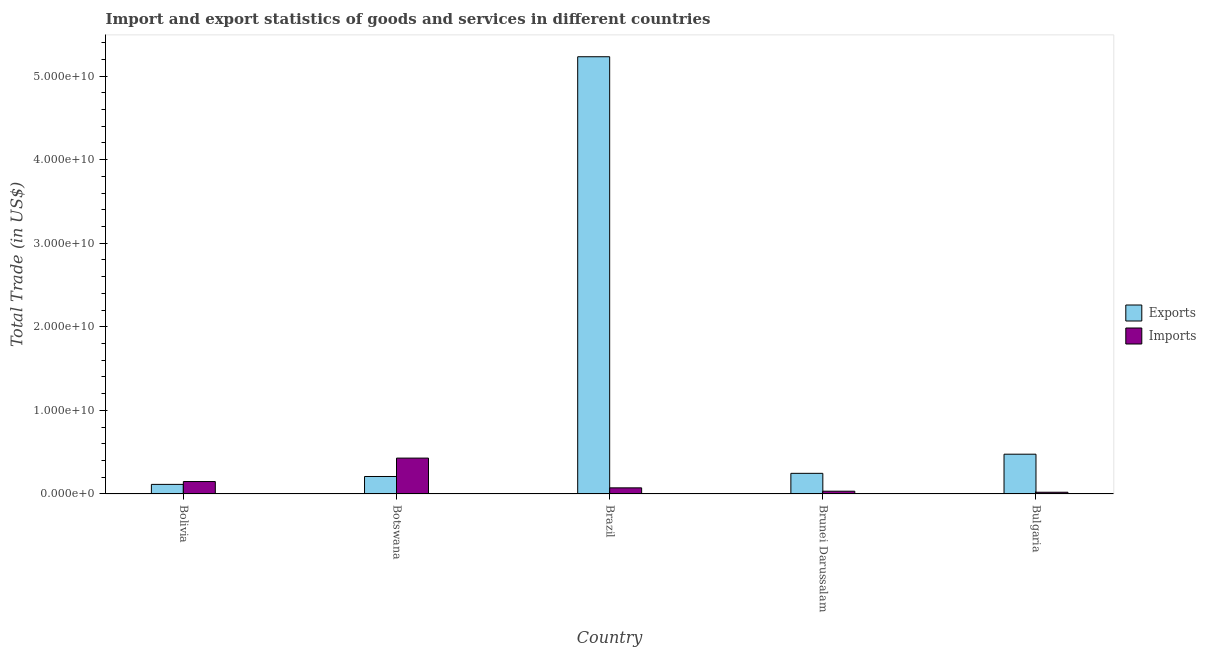How many groups of bars are there?
Ensure brevity in your answer.  5. Are the number of bars per tick equal to the number of legend labels?
Provide a succinct answer. Yes. Are the number of bars on each tick of the X-axis equal?
Make the answer very short. Yes. How many bars are there on the 5th tick from the left?
Provide a short and direct response. 2. How many bars are there on the 4th tick from the right?
Give a very brief answer. 2. In how many cases, is the number of bars for a given country not equal to the number of legend labels?
Your answer should be very brief. 0. What is the export of goods and services in Brunei Darussalam?
Provide a short and direct response. 2.47e+09. Across all countries, what is the maximum export of goods and services?
Provide a short and direct response. 5.23e+1. Across all countries, what is the minimum imports of goods and services?
Offer a terse response. 2.06e+08. What is the total imports of goods and services in the graph?
Offer a terse response. 7.05e+09. What is the difference between the export of goods and services in Brazil and that in Brunei Darussalam?
Ensure brevity in your answer.  4.98e+1. What is the difference between the export of goods and services in Brunei Darussalam and the imports of goods and services in Bulgaria?
Your answer should be compact. 2.26e+09. What is the average imports of goods and services per country?
Make the answer very short. 1.41e+09. What is the difference between the export of goods and services and imports of goods and services in Bulgaria?
Provide a short and direct response. 4.55e+09. What is the ratio of the imports of goods and services in Brazil to that in Brunei Darussalam?
Provide a short and direct response. 2.2. Is the imports of goods and services in Bolivia less than that in Brunei Darussalam?
Give a very brief answer. No. What is the difference between the highest and the second highest export of goods and services?
Provide a short and direct response. 4.76e+1. What is the difference between the highest and the lowest imports of goods and services?
Keep it short and to the point. 4.08e+09. What does the 1st bar from the left in Brunei Darussalam represents?
Make the answer very short. Exports. What does the 2nd bar from the right in Brazil represents?
Provide a succinct answer. Exports. Are all the bars in the graph horizontal?
Your answer should be very brief. No. How many countries are there in the graph?
Make the answer very short. 5. Are the values on the major ticks of Y-axis written in scientific E-notation?
Ensure brevity in your answer.  Yes. Does the graph contain grids?
Offer a very short reply. No. Where does the legend appear in the graph?
Ensure brevity in your answer.  Center right. How are the legend labels stacked?
Provide a short and direct response. Vertical. What is the title of the graph?
Your answer should be compact. Import and export statistics of goods and services in different countries. Does "Nitrous oxide" appear as one of the legend labels in the graph?
Make the answer very short. No. What is the label or title of the X-axis?
Make the answer very short. Country. What is the label or title of the Y-axis?
Your answer should be compact. Total Trade (in US$). What is the Total Trade (in US$) of Exports in Bolivia?
Your response must be concise. 1.15e+09. What is the Total Trade (in US$) in Imports in Bolivia?
Offer a very short reply. 1.49e+09. What is the Total Trade (in US$) in Exports in Botswana?
Provide a short and direct response. 2.09e+09. What is the Total Trade (in US$) in Imports in Botswana?
Ensure brevity in your answer.  4.29e+09. What is the Total Trade (in US$) in Exports in Brazil?
Offer a terse response. 5.23e+1. What is the Total Trade (in US$) in Imports in Brazil?
Ensure brevity in your answer.  7.32e+08. What is the Total Trade (in US$) in Exports in Brunei Darussalam?
Ensure brevity in your answer.  2.47e+09. What is the Total Trade (in US$) of Imports in Brunei Darussalam?
Your answer should be very brief. 3.33e+08. What is the Total Trade (in US$) in Exports in Bulgaria?
Provide a succinct answer. 4.76e+09. What is the Total Trade (in US$) in Imports in Bulgaria?
Offer a terse response. 2.06e+08. Across all countries, what is the maximum Total Trade (in US$) in Exports?
Provide a short and direct response. 5.23e+1. Across all countries, what is the maximum Total Trade (in US$) of Imports?
Make the answer very short. 4.29e+09. Across all countries, what is the minimum Total Trade (in US$) in Exports?
Give a very brief answer. 1.15e+09. Across all countries, what is the minimum Total Trade (in US$) of Imports?
Provide a short and direct response. 2.06e+08. What is the total Total Trade (in US$) of Exports in the graph?
Your answer should be compact. 6.28e+1. What is the total Total Trade (in US$) in Imports in the graph?
Provide a succinct answer. 7.05e+09. What is the difference between the Total Trade (in US$) of Exports in Bolivia and that in Botswana?
Your response must be concise. -9.43e+08. What is the difference between the Total Trade (in US$) in Imports in Bolivia and that in Botswana?
Provide a short and direct response. -2.80e+09. What is the difference between the Total Trade (in US$) of Exports in Bolivia and that in Brazil?
Offer a terse response. -5.12e+1. What is the difference between the Total Trade (in US$) in Imports in Bolivia and that in Brazil?
Keep it short and to the point. 7.55e+08. What is the difference between the Total Trade (in US$) of Exports in Bolivia and that in Brunei Darussalam?
Your answer should be very brief. -1.32e+09. What is the difference between the Total Trade (in US$) of Imports in Bolivia and that in Brunei Darussalam?
Offer a terse response. 1.15e+09. What is the difference between the Total Trade (in US$) in Exports in Bolivia and that in Bulgaria?
Provide a succinct answer. -3.61e+09. What is the difference between the Total Trade (in US$) in Imports in Bolivia and that in Bulgaria?
Keep it short and to the point. 1.28e+09. What is the difference between the Total Trade (in US$) of Exports in Botswana and that in Brazil?
Provide a succinct answer. -5.02e+1. What is the difference between the Total Trade (in US$) in Imports in Botswana and that in Brazil?
Keep it short and to the point. 3.56e+09. What is the difference between the Total Trade (in US$) of Exports in Botswana and that in Brunei Darussalam?
Your response must be concise. -3.77e+08. What is the difference between the Total Trade (in US$) of Imports in Botswana and that in Brunei Darussalam?
Make the answer very short. 3.96e+09. What is the difference between the Total Trade (in US$) of Exports in Botswana and that in Bulgaria?
Your answer should be very brief. -2.67e+09. What is the difference between the Total Trade (in US$) in Imports in Botswana and that in Bulgaria?
Offer a very short reply. 4.08e+09. What is the difference between the Total Trade (in US$) of Exports in Brazil and that in Brunei Darussalam?
Make the answer very short. 4.98e+1. What is the difference between the Total Trade (in US$) in Imports in Brazil and that in Brunei Darussalam?
Your answer should be compact. 3.99e+08. What is the difference between the Total Trade (in US$) of Exports in Brazil and that in Bulgaria?
Your answer should be compact. 4.76e+1. What is the difference between the Total Trade (in US$) in Imports in Brazil and that in Bulgaria?
Provide a succinct answer. 5.26e+08. What is the difference between the Total Trade (in US$) in Exports in Brunei Darussalam and that in Bulgaria?
Ensure brevity in your answer.  -2.29e+09. What is the difference between the Total Trade (in US$) in Imports in Brunei Darussalam and that in Bulgaria?
Keep it short and to the point. 1.27e+08. What is the difference between the Total Trade (in US$) of Exports in Bolivia and the Total Trade (in US$) of Imports in Botswana?
Provide a succinct answer. -3.14e+09. What is the difference between the Total Trade (in US$) of Exports in Bolivia and the Total Trade (in US$) of Imports in Brazil?
Give a very brief answer. 4.16e+08. What is the difference between the Total Trade (in US$) in Exports in Bolivia and the Total Trade (in US$) in Imports in Brunei Darussalam?
Provide a short and direct response. 8.15e+08. What is the difference between the Total Trade (in US$) of Exports in Bolivia and the Total Trade (in US$) of Imports in Bulgaria?
Provide a short and direct response. 9.42e+08. What is the difference between the Total Trade (in US$) of Exports in Botswana and the Total Trade (in US$) of Imports in Brazil?
Offer a very short reply. 1.36e+09. What is the difference between the Total Trade (in US$) of Exports in Botswana and the Total Trade (in US$) of Imports in Brunei Darussalam?
Offer a terse response. 1.76e+09. What is the difference between the Total Trade (in US$) in Exports in Botswana and the Total Trade (in US$) in Imports in Bulgaria?
Provide a succinct answer. 1.88e+09. What is the difference between the Total Trade (in US$) of Exports in Brazil and the Total Trade (in US$) of Imports in Brunei Darussalam?
Ensure brevity in your answer.  5.20e+1. What is the difference between the Total Trade (in US$) of Exports in Brazil and the Total Trade (in US$) of Imports in Bulgaria?
Your answer should be very brief. 5.21e+1. What is the difference between the Total Trade (in US$) in Exports in Brunei Darussalam and the Total Trade (in US$) in Imports in Bulgaria?
Make the answer very short. 2.26e+09. What is the average Total Trade (in US$) in Exports per country?
Provide a succinct answer. 1.26e+1. What is the average Total Trade (in US$) in Imports per country?
Your answer should be very brief. 1.41e+09. What is the difference between the Total Trade (in US$) in Exports and Total Trade (in US$) in Imports in Bolivia?
Provide a short and direct response. -3.39e+08. What is the difference between the Total Trade (in US$) of Exports and Total Trade (in US$) of Imports in Botswana?
Make the answer very short. -2.20e+09. What is the difference between the Total Trade (in US$) in Exports and Total Trade (in US$) in Imports in Brazil?
Your answer should be very brief. 5.16e+1. What is the difference between the Total Trade (in US$) of Exports and Total Trade (in US$) of Imports in Brunei Darussalam?
Provide a short and direct response. 2.14e+09. What is the difference between the Total Trade (in US$) of Exports and Total Trade (in US$) of Imports in Bulgaria?
Provide a succinct answer. 4.55e+09. What is the ratio of the Total Trade (in US$) of Exports in Bolivia to that in Botswana?
Provide a short and direct response. 0.55. What is the ratio of the Total Trade (in US$) of Imports in Bolivia to that in Botswana?
Offer a very short reply. 0.35. What is the ratio of the Total Trade (in US$) of Exports in Bolivia to that in Brazil?
Ensure brevity in your answer.  0.02. What is the ratio of the Total Trade (in US$) of Imports in Bolivia to that in Brazil?
Offer a very short reply. 2.03. What is the ratio of the Total Trade (in US$) in Exports in Bolivia to that in Brunei Darussalam?
Offer a terse response. 0.47. What is the ratio of the Total Trade (in US$) of Imports in Bolivia to that in Brunei Darussalam?
Give a very brief answer. 4.47. What is the ratio of the Total Trade (in US$) in Exports in Bolivia to that in Bulgaria?
Make the answer very short. 0.24. What is the ratio of the Total Trade (in US$) in Imports in Bolivia to that in Bulgaria?
Your answer should be very brief. 7.22. What is the ratio of the Total Trade (in US$) of Imports in Botswana to that in Brazil?
Your answer should be very brief. 5.86. What is the ratio of the Total Trade (in US$) of Exports in Botswana to that in Brunei Darussalam?
Provide a short and direct response. 0.85. What is the ratio of the Total Trade (in US$) of Imports in Botswana to that in Brunei Darussalam?
Offer a terse response. 12.89. What is the ratio of the Total Trade (in US$) of Exports in Botswana to that in Bulgaria?
Provide a succinct answer. 0.44. What is the ratio of the Total Trade (in US$) of Imports in Botswana to that in Bulgaria?
Make the answer very short. 20.83. What is the ratio of the Total Trade (in US$) of Exports in Brazil to that in Brunei Darussalam?
Keep it short and to the point. 21.19. What is the ratio of the Total Trade (in US$) in Imports in Brazil to that in Brunei Darussalam?
Provide a succinct answer. 2.2. What is the ratio of the Total Trade (in US$) in Exports in Brazil to that in Bulgaria?
Keep it short and to the point. 10.99. What is the ratio of the Total Trade (in US$) of Imports in Brazil to that in Bulgaria?
Provide a short and direct response. 3.55. What is the ratio of the Total Trade (in US$) of Exports in Brunei Darussalam to that in Bulgaria?
Your response must be concise. 0.52. What is the ratio of the Total Trade (in US$) of Imports in Brunei Darussalam to that in Bulgaria?
Keep it short and to the point. 1.62. What is the difference between the highest and the second highest Total Trade (in US$) in Exports?
Provide a succinct answer. 4.76e+1. What is the difference between the highest and the second highest Total Trade (in US$) of Imports?
Offer a very short reply. 2.80e+09. What is the difference between the highest and the lowest Total Trade (in US$) in Exports?
Make the answer very short. 5.12e+1. What is the difference between the highest and the lowest Total Trade (in US$) in Imports?
Your response must be concise. 4.08e+09. 